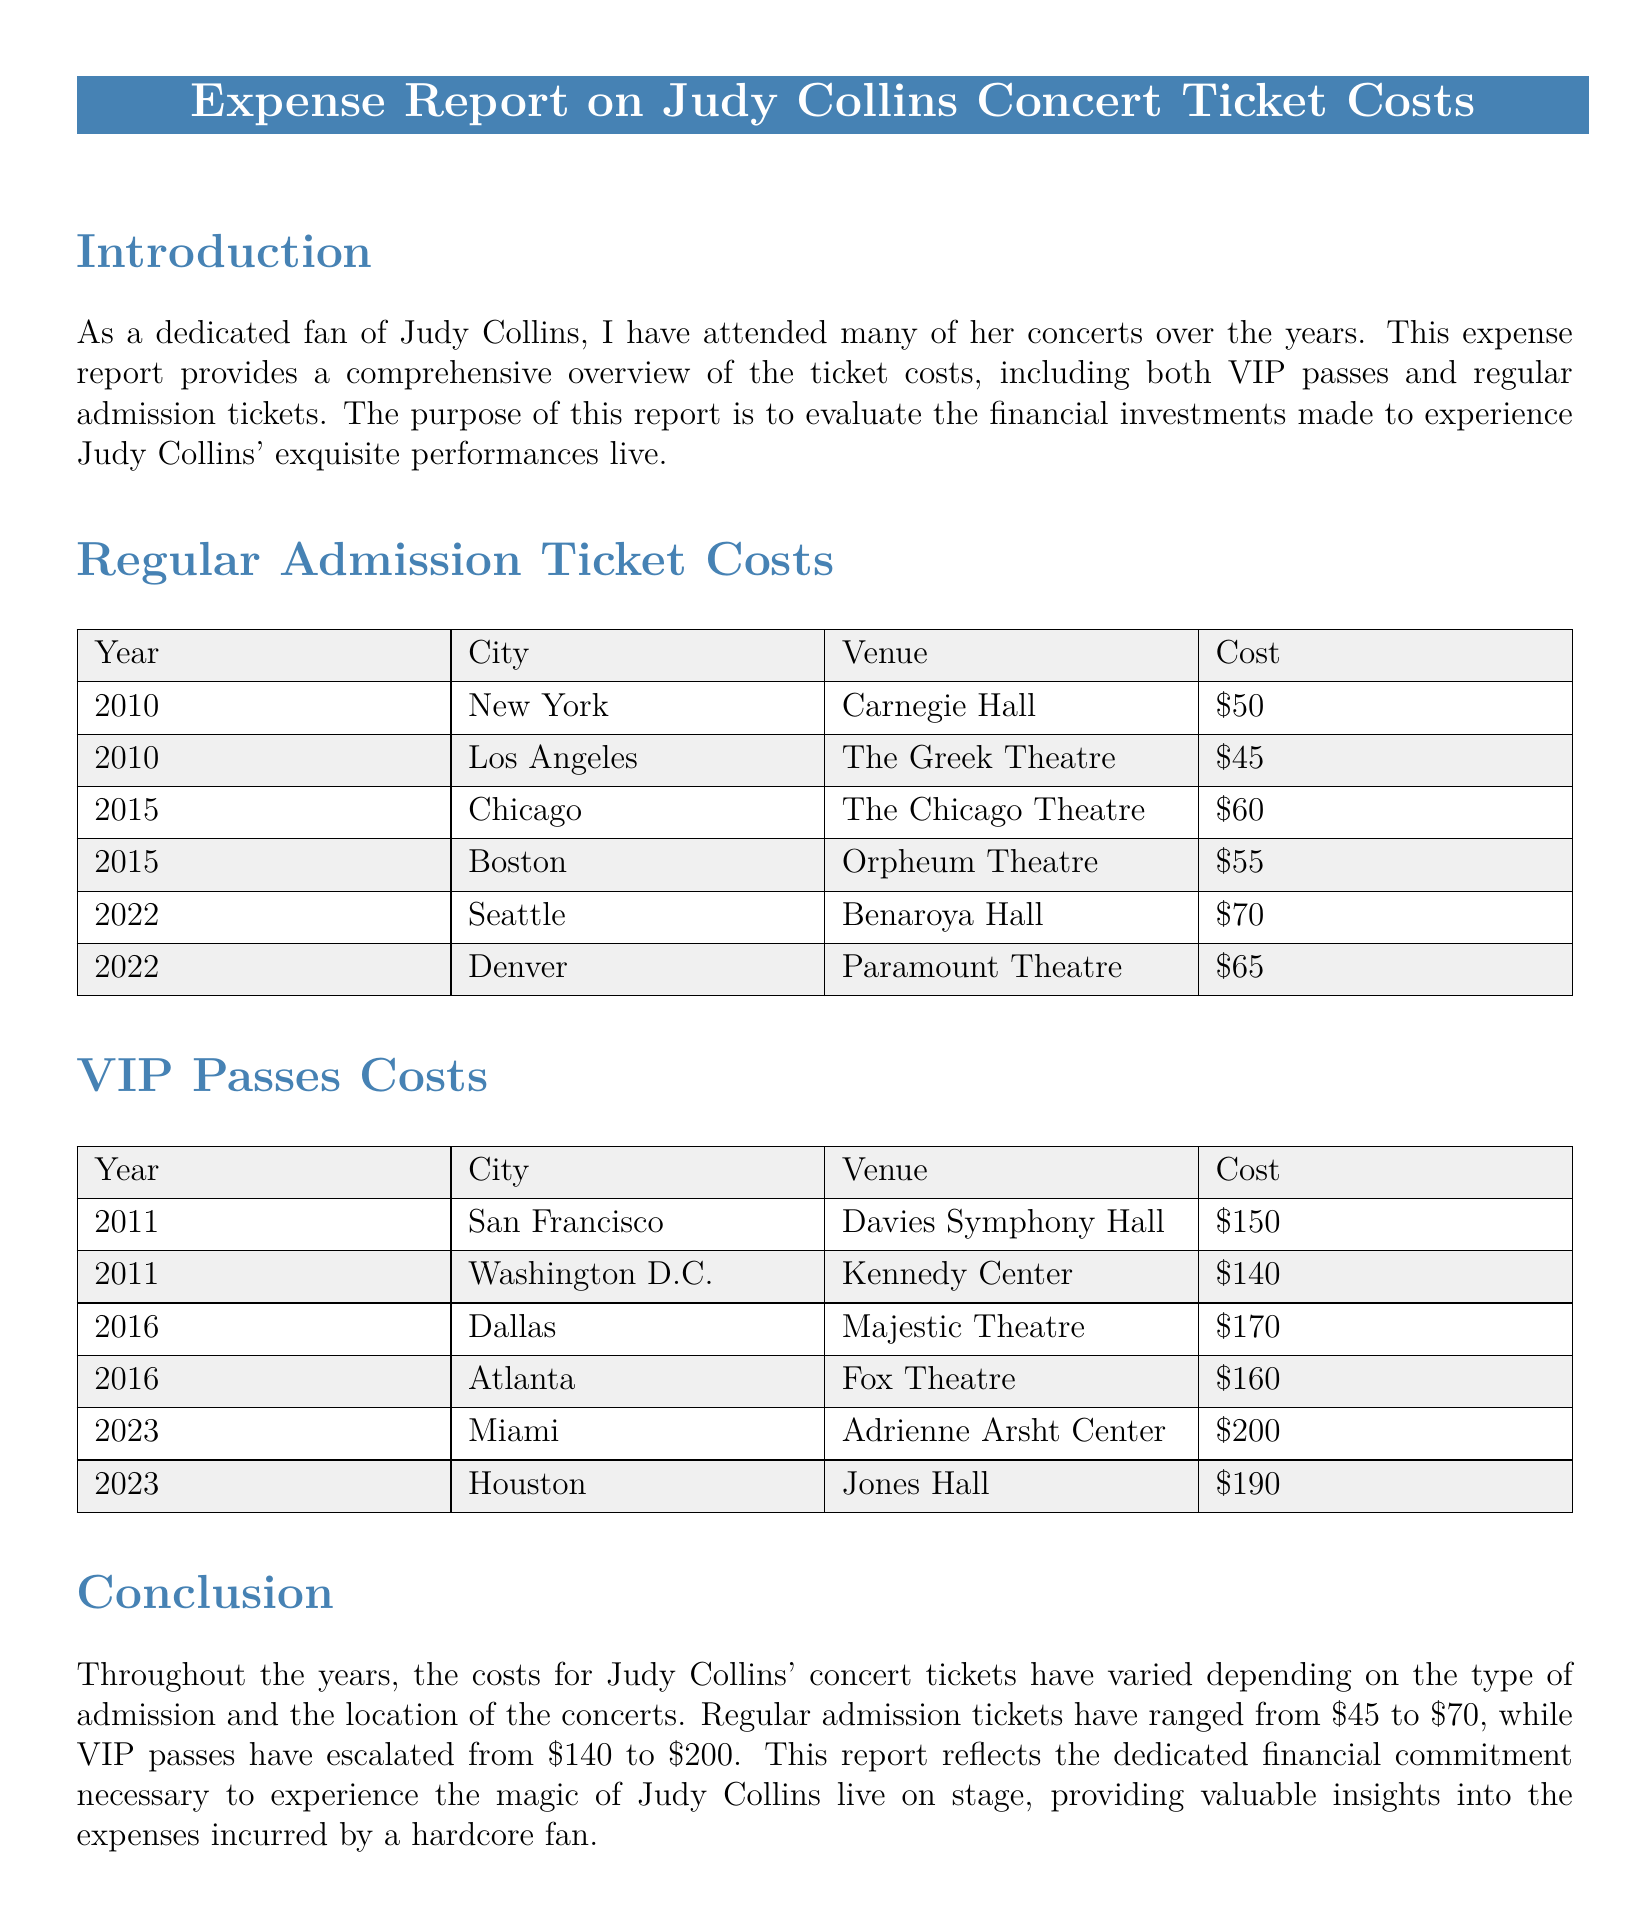What is the cost of a regular admission ticket in Seattle? The cost for a regular admission ticket in Seattle in 2022 is listed in the table.
Answer: $70 Which venue hosted Judy Collins in Boston in 2015? The document includes a table with details of concert venues, and Boston is associated with the Orpheum Theatre.
Answer: Orpheum Theatre What was the VIP pass cost in Houston in 2023? The document states the cost of VIP passes for Houston in 2023 can be found in the provided table.
Answer: $190 How many years are represented in the ticket cost data? The data spans various concerts, each listed by year, allowing for straightforward counting of unique years.
Answer: 6 Which city had the cheapest regular admission ticket? The document lists the regular ticket costs, with the lowest amount found in the first table.
Answer: Los Angeles What is the highest cost for a VIP pass in the document? Upon reviewing the VIP pass costs, we can identify the highest entry from the table.
Answer: $200 In what year did the ticket costs for VIP passes increase to over $180? The increase in VIP pass costs can be traced through the years specified in the document.
Answer: 2016 What was the cost of the concert ticket in New York in 2010? The document explicitly lists the costs associated with each venue and year, revealing the New York price.
Answer: $50 